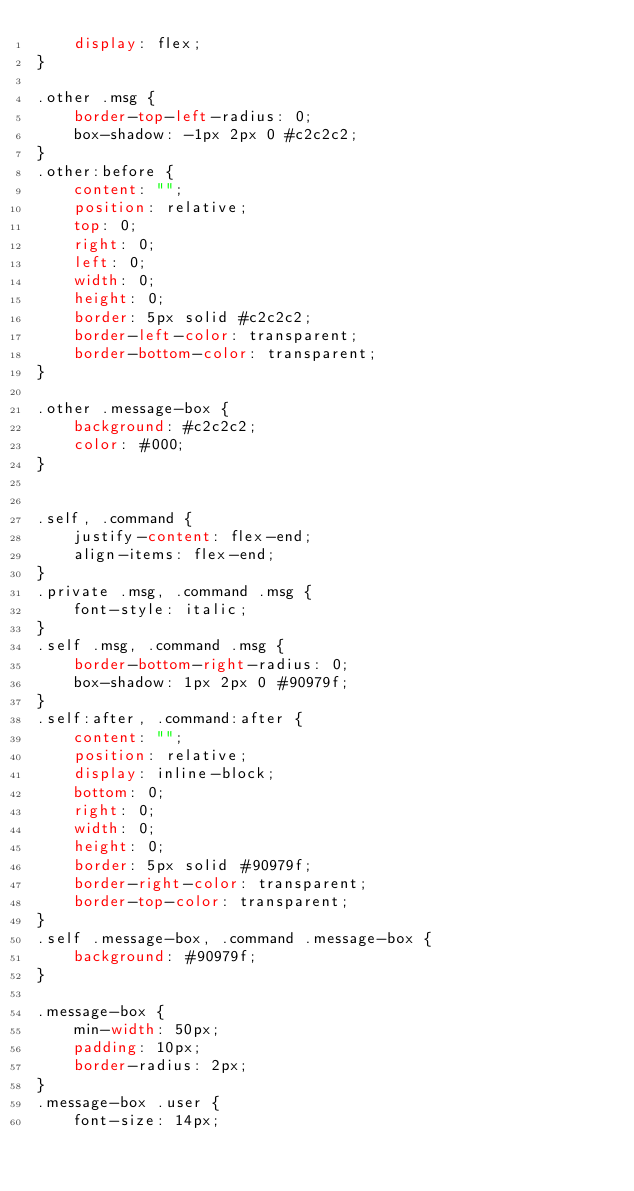Convert code to text. <code><loc_0><loc_0><loc_500><loc_500><_CSS_>    display: flex;
}

.other .msg {
    border-top-left-radius: 0;
    box-shadow: -1px 2px 0 #c2c2c2;
}
.other:before {
    content: "";
    position: relative;
    top: 0;
    right: 0;
    left: 0;
    width: 0;
    height: 0;
    border: 5px solid #c2c2c2;
    border-left-color: transparent;
    border-bottom-color: transparent;
}

.other .message-box {
    background: #c2c2c2;
    color: #000;
}


.self, .command {
    justify-content: flex-end;
    align-items: flex-end;
}
.private .msg, .command .msg {
    font-style: italic;
}
.self .msg, .command .msg {
    border-bottom-right-radius: 0;
    box-shadow: 1px 2px 0 #90979f;
}
.self:after, .command:after {
    content: "";
    position: relative;
    display: inline-block;
    bottom: 0;
    right: 0;
    width: 0;
    height: 0;
    border: 5px solid #90979f;
    border-right-color: transparent;
    border-top-color: transparent;
}
.self .message-box, .command .message-box {
    background: #90979f;
}

.message-box {
    min-width: 50px;
    padding: 10px;
    border-radius: 2px;
}
.message-box .user {
    font-size: 14px;</code> 